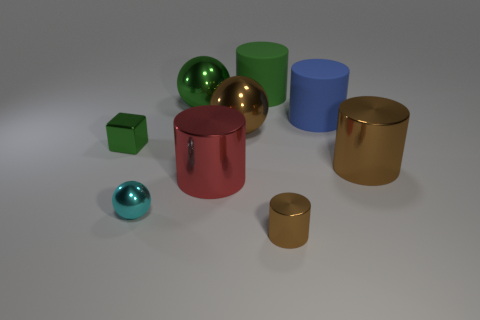Subtract all red cylinders. How many cylinders are left? 4 Subtract all blue cylinders. How many cylinders are left? 4 Subtract all cyan cylinders. Subtract all gray blocks. How many cylinders are left? 5 Add 1 brown spheres. How many objects exist? 10 Subtract all cylinders. How many objects are left? 4 Add 5 gray matte objects. How many gray matte objects exist? 5 Subtract 2 brown cylinders. How many objects are left? 7 Subtract all large brown cylinders. Subtract all balls. How many objects are left? 5 Add 4 small green metallic things. How many small green metallic things are left? 5 